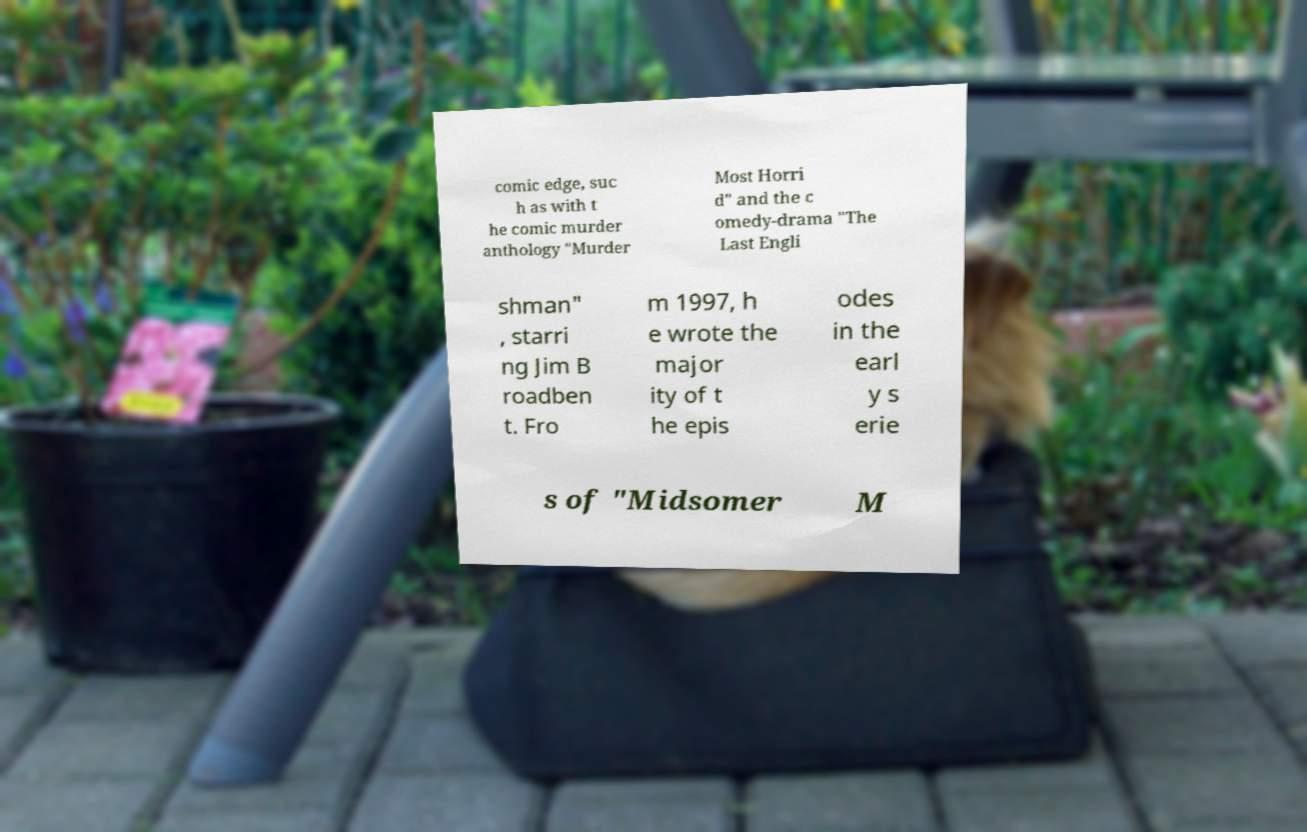I need the written content from this picture converted into text. Can you do that? comic edge, suc h as with t he comic murder anthology "Murder Most Horri d" and the c omedy-drama "The Last Engli shman" , starri ng Jim B roadben t. Fro m 1997, h e wrote the major ity of t he epis odes in the earl y s erie s of "Midsomer M 